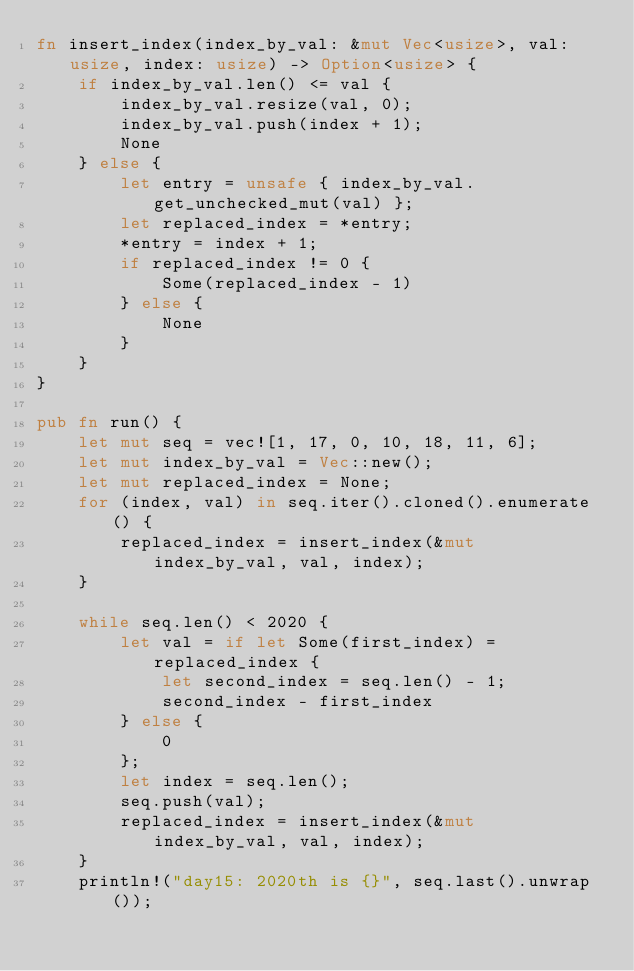Convert code to text. <code><loc_0><loc_0><loc_500><loc_500><_Rust_>fn insert_index(index_by_val: &mut Vec<usize>, val: usize, index: usize) -> Option<usize> {
    if index_by_val.len() <= val {
        index_by_val.resize(val, 0);
        index_by_val.push(index + 1);
        None
    } else {
        let entry = unsafe { index_by_val.get_unchecked_mut(val) };
        let replaced_index = *entry;
        *entry = index + 1;
        if replaced_index != 0 {
            Some(replaced_index - 1)
        } else {
            None
        }
    }
}

pub fn run() {
    let mut seq = vec![1, 17, 0, 10, 18, 11, 6];
    let mut index_by_val = Vec::new();
    let mut replaced_index = None;
    for (index, val) in seq.iter().cloned().enumerate() {
        replaced_index = insert_index(&mut index_by_val, val, index);
    }

    while seq.len() < 2020 {
        let val = if let Some(first_index) = replaced_index {
            let second_index = seq.len() - 1;
            second_index - first_index
        } else {
            0
        };
        let index = seq.len();
        seq.push(val);
        replaced_index = insert_index(&mut index_by_val, val, index);
    }
    println!("day15: 2020th is {}", seq.last().unwrap());
</code> 